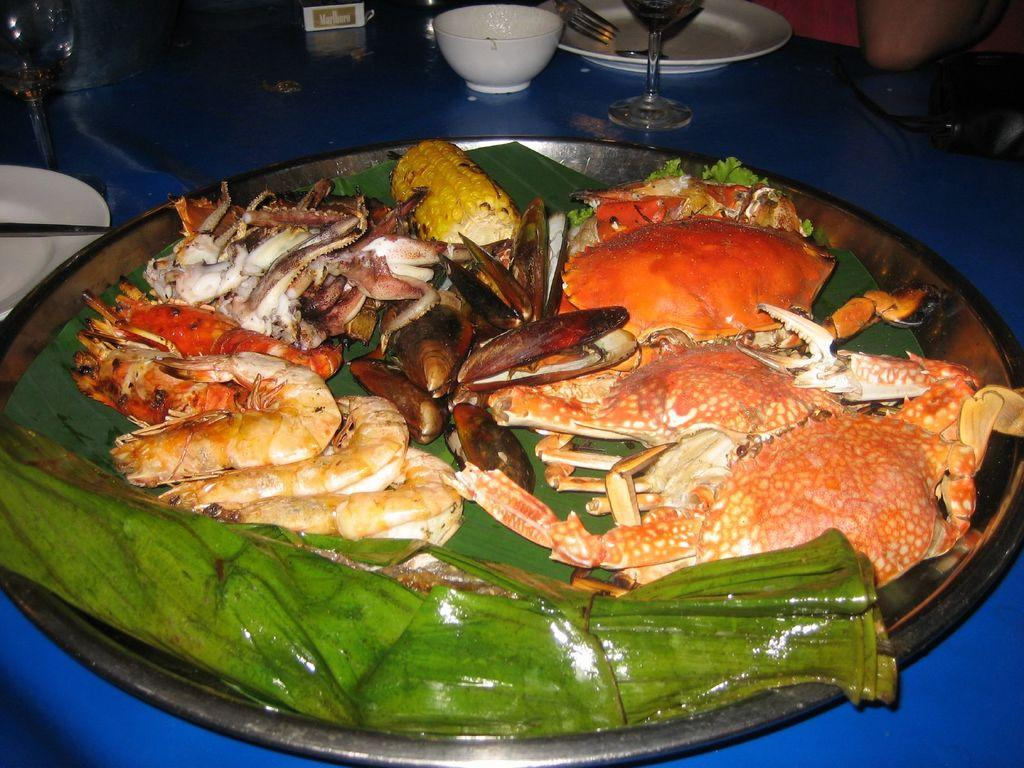What is the main surface used for holding food items in the image? There are food items on a leaf in the image. What other dishware is present in the image? There is a plate and a bowl in the image. How many plates are visible in the image? There are multiple plates in the image. What utensil is present in the image? There is a fork in the image. What type of drinkware is present in the image? There are glasses in the image. What is on the table in the image? There are items on the table in the image. Can you describe the person in the background of the image? There is a person in the background of the image, but no specific details are provided. What color is the person's eye in the image? There is no person's eye visible in the image; only a person in the background is mentioned. What type of slip is present on the sidewalk in the image? There is no sidewalk or slip present in the image. 